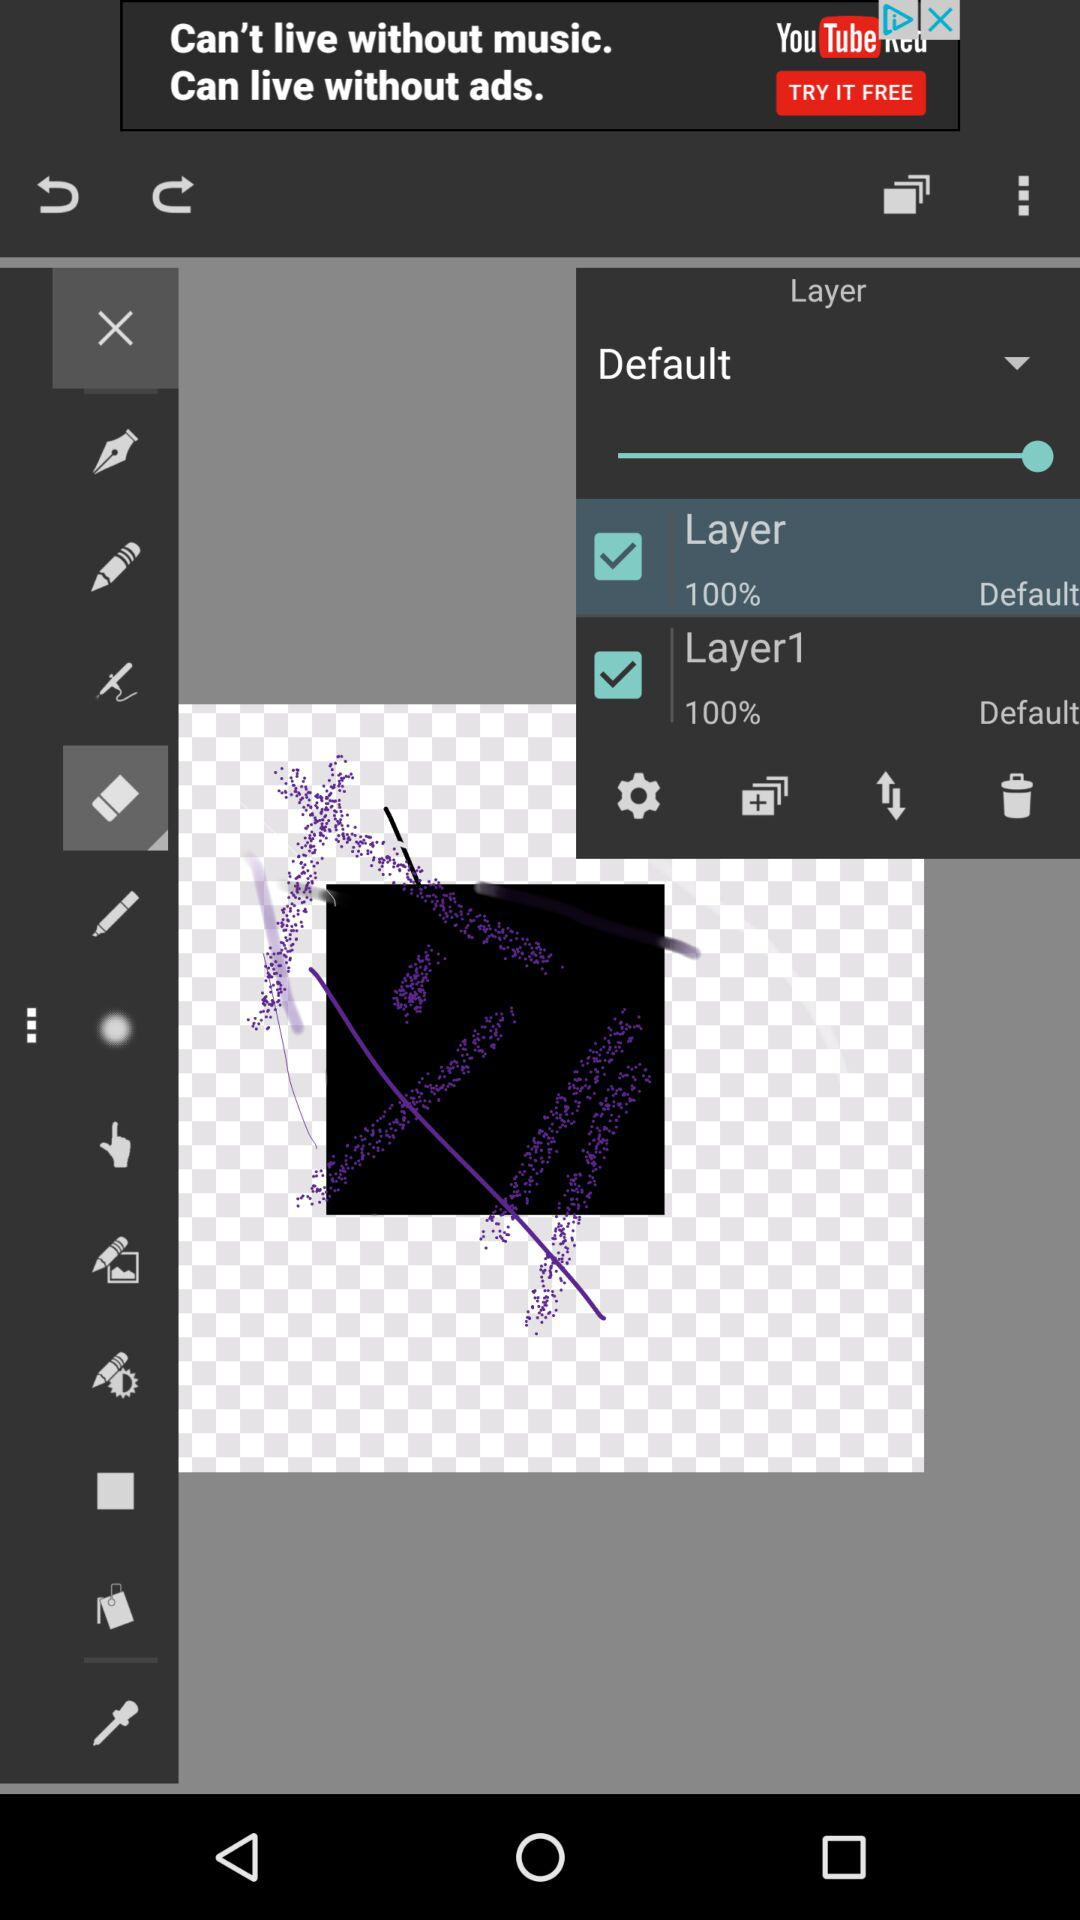What is the status of the "Layer" option? The status is "on". 